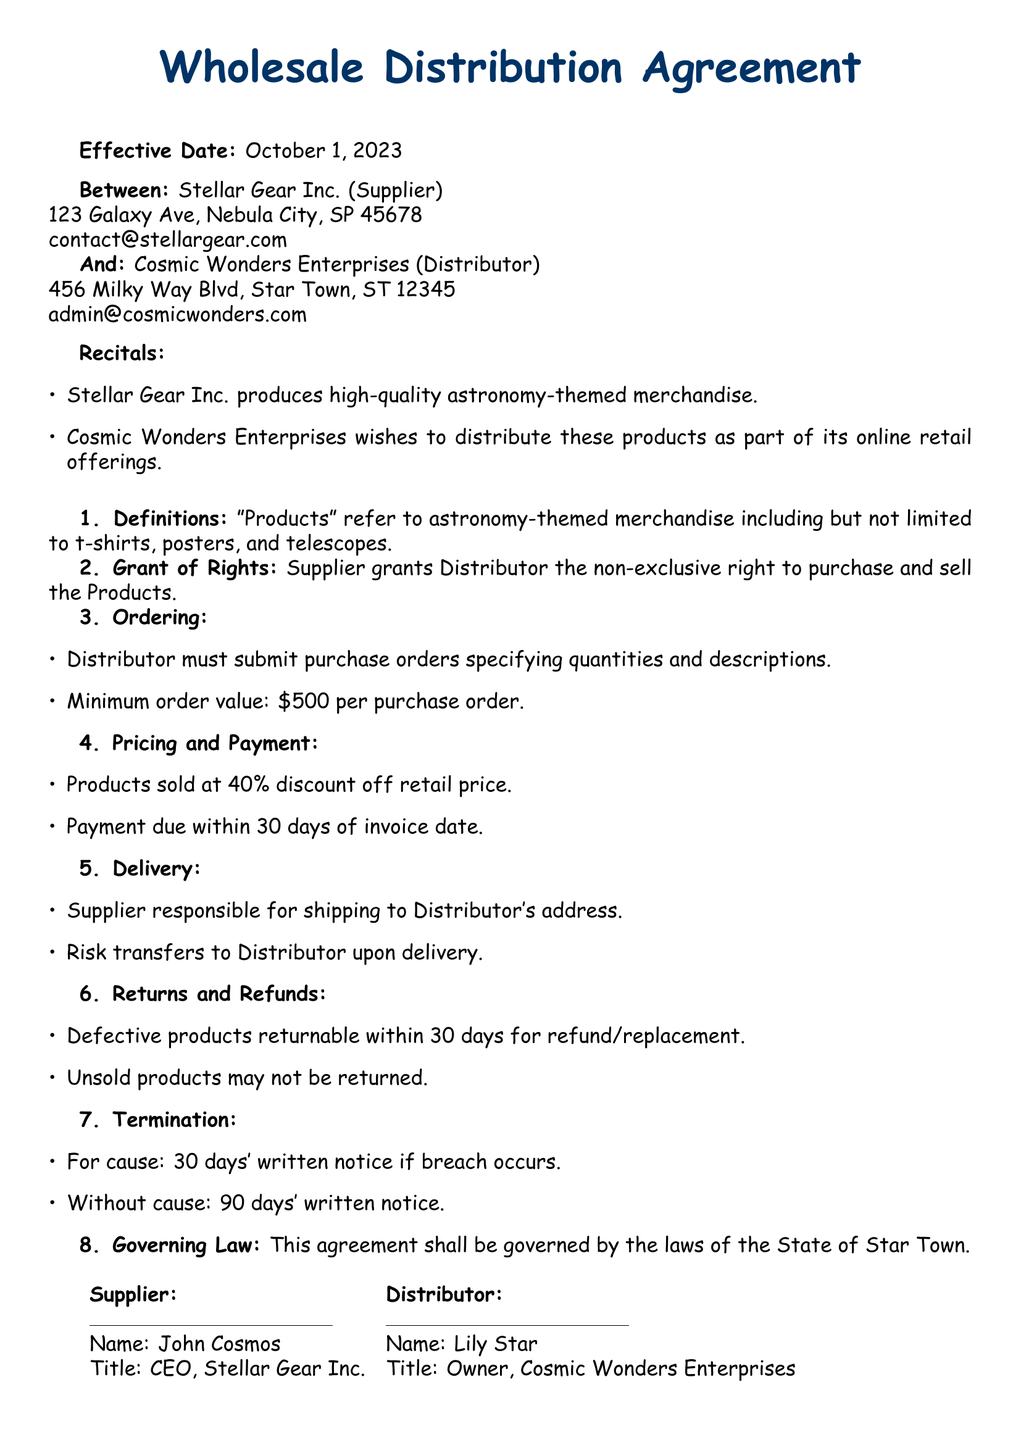What is the effective date of the agreement? The effective date is specified clearly in the document as the date when the agreement comes into force.
Answer: October 1, 2023 Who are the Supplier and Distributor? The document identifies the parties involved in the agreement by their official names.
Answer: Stellar Gear Inc. and Cosmic Wonders Enterprises What is the minimum order value? The document specifies a financial threshold that must be met for each purchase order.
Answer: $500 What discount does the Distributor receive on the retail price? The agreement states the percentage discount the Distributor gets on the regular pricing of products.
Answer: 40% How many days does the Distributor have to pay after receiving the invoice? The payment terms outline the period within which the Distributor must settle their invoices.
Answer: 30 days What happens if the Supplier breaches the agreement? The document details the conditions under which either party can terminate the agreement if specific issues arise.
Answer: 30 days' written notice Can unsold products be returned? The terms related to returns and refunds clarify the policy regarding products that are not sold.
Answer: No Which state's laws govern this agreement? The governing law section indicates the legal jurisdiction applicable to the contract.
Answer: Star Town 